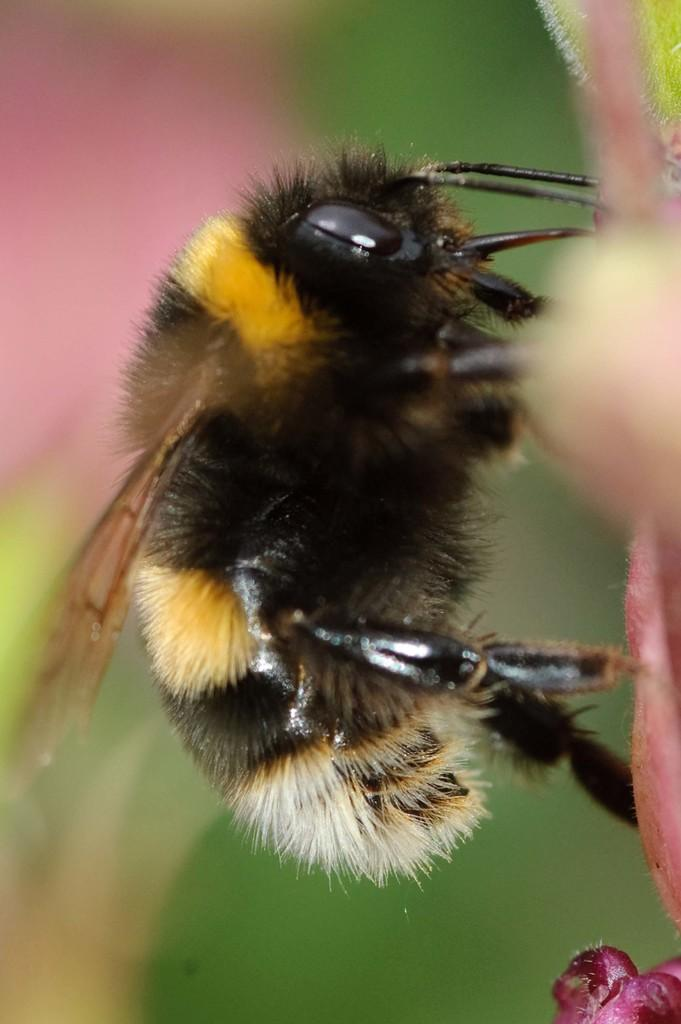What can be observed about the background of the picture? The background portion of the picture is blurred. What is present in the picture besides the blurred background? There is an insect in the picture. Which side of the picture is blurry? The left side of the picture is blurry. Can you tell me how many basketballs are visible in the picture? There are no basketballs present in the image. What type of mark can be seen on the insect in the picture? There is no mention of any mark on the insect in the provided facts, so we cannot determine if there is a mark or not. 